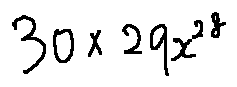<formula> <loc_0><loc_0><loc_500><loc_500>3 0 \times 2 9 x ^ { 2 8 }</formula> 